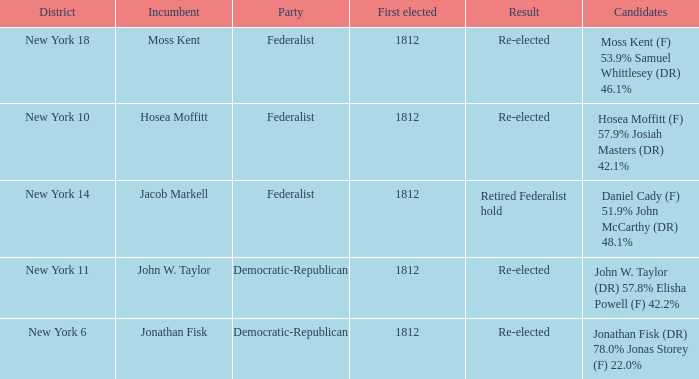Name the incumbent for new york 10 Hosea Moffitt. 